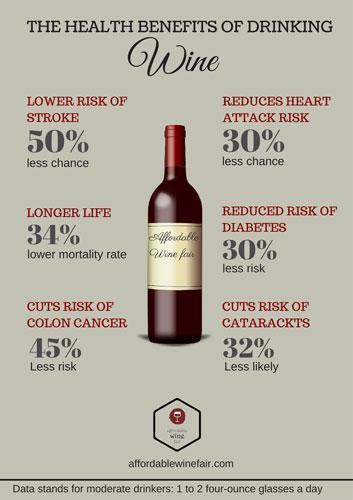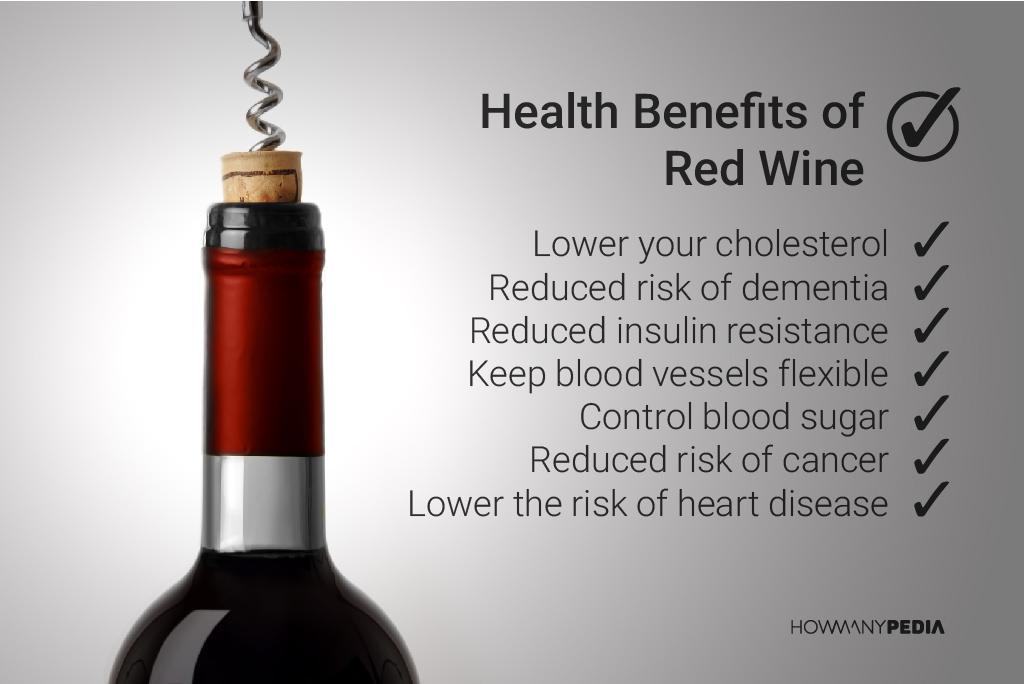The first image is the image on the left, the second image is the image on the right. For the images shown, is this caption "Images show a total of three wine bottles." true? Answer yes or no. No. 